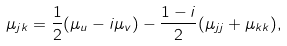<formula> <loc_0><loc_0><loc_500><loc_500>\mu _ { j k } = \frac { 1 } { 2 } ( \mu _ { u } - i \mu _ { v } ) - \frac { 1 - i } { 2 } ( \mu _ { j j } + \mu _ { k k } ) ,</formula> 